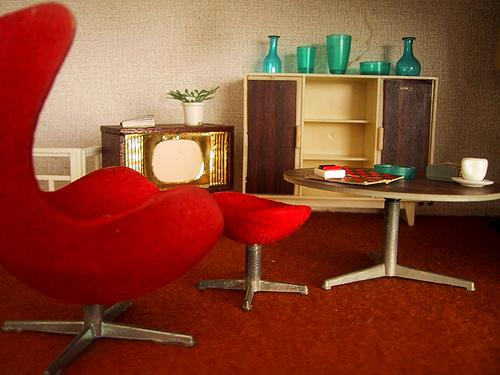This style of furniture was popular in what era? seventies 